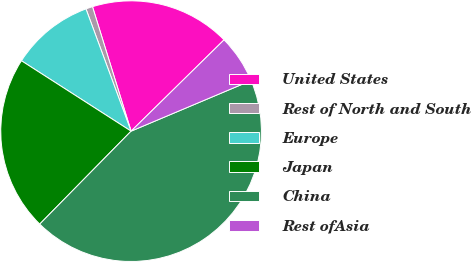<chart> <loc_0><loc_0><loc_500><loc_500><pie_chart><fcel>United States<fcel>Rest of North and South<fcel>Europe<fcel>Japan<fcel>China<fcel>Rest ofAsia<nl><fcel>17.43%<fcel>0.84%<fcel>10.29%<fcel>21.72%<fcel>43.72%<fcel>6.0%<nl></chart> 